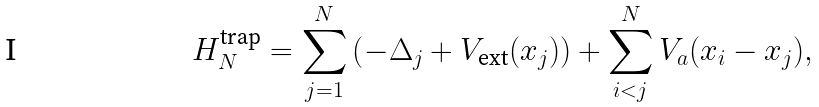<formula> <loc_0><loc_0><loc_500><loc_500>H ^ { \text {trap} } _ { N } = \sum _ { j = 1 } ^ { N } \left ( - \Delta _ { j } + V _ { \text {ext} } ( x _ { j } ) \right ) + \sum _ { i < j } ^ { N } V _ { a } ( x _ { i } - x _ { j } ) ,</formula> 